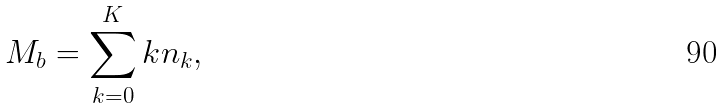Convert formula to latex. <formula><loc_0><loc_0><loc_500><loc_500>M _ { b } = \sum _ { k = 0 } ^ { K } k n _ { k } ,</formula> 